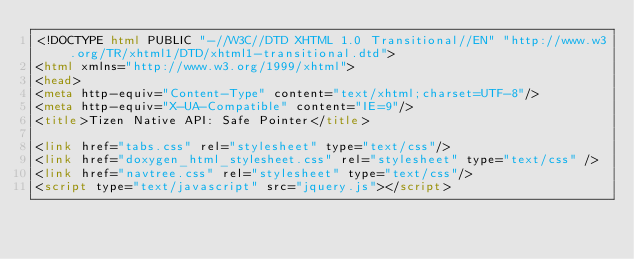<code> <loc_0><loc_0><loc_500><loc_500><_HTML_><!DOCTYPE html PUBLIC "-//W3C//DTD XHTML 1.0 Transitional//EN" "http://www.w3.org/TR/xhtml1/DTD/xhtml1-transitional.dtd">
<html xmlns="http://www.w3.org/1999/xhtml">
<head>
<meta http-equiv="Content-Type" content="text/xhtml;charset=UTF-8"/>
<meta http-equiv="X-UA-Compatible" content="IE=9"/>
<title>Tizen Native API: Safe Pointer</title>

<link href="tabs.css" rel="stylesheet" type="text/css"/>
<link href="doxygen_html_stylesheet.css" rel="stylesheet" type="text/css" />
<link href="navtree.css" rel="stylesheet" type="text/css"/>
<script type="text/javascript" src="jquery.js"></script></code> 